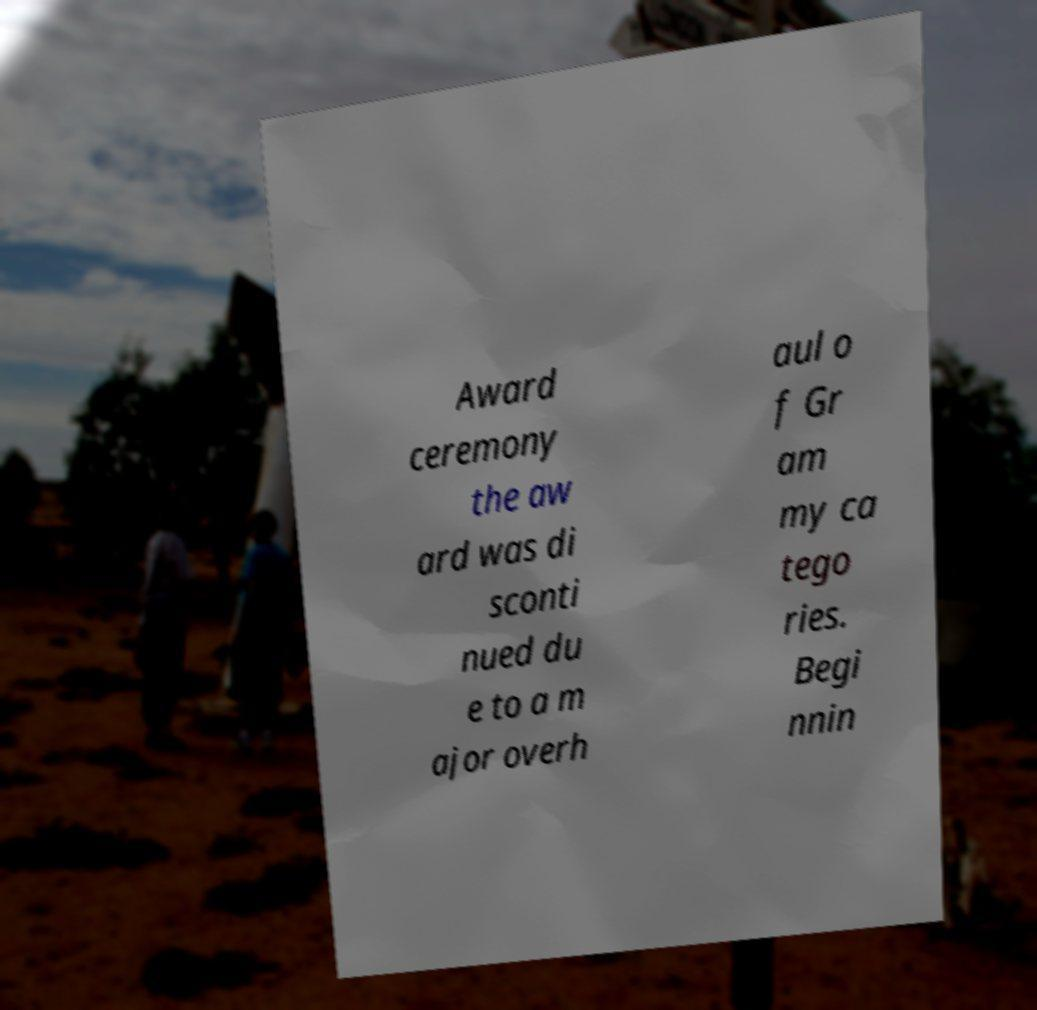I need the written content from this picture converted into text. Can you do that? Award ceremony the aw ard was di sconti nued du e to a m ajor overh aul o f Gr am my ca tego ries. Begi nnin 